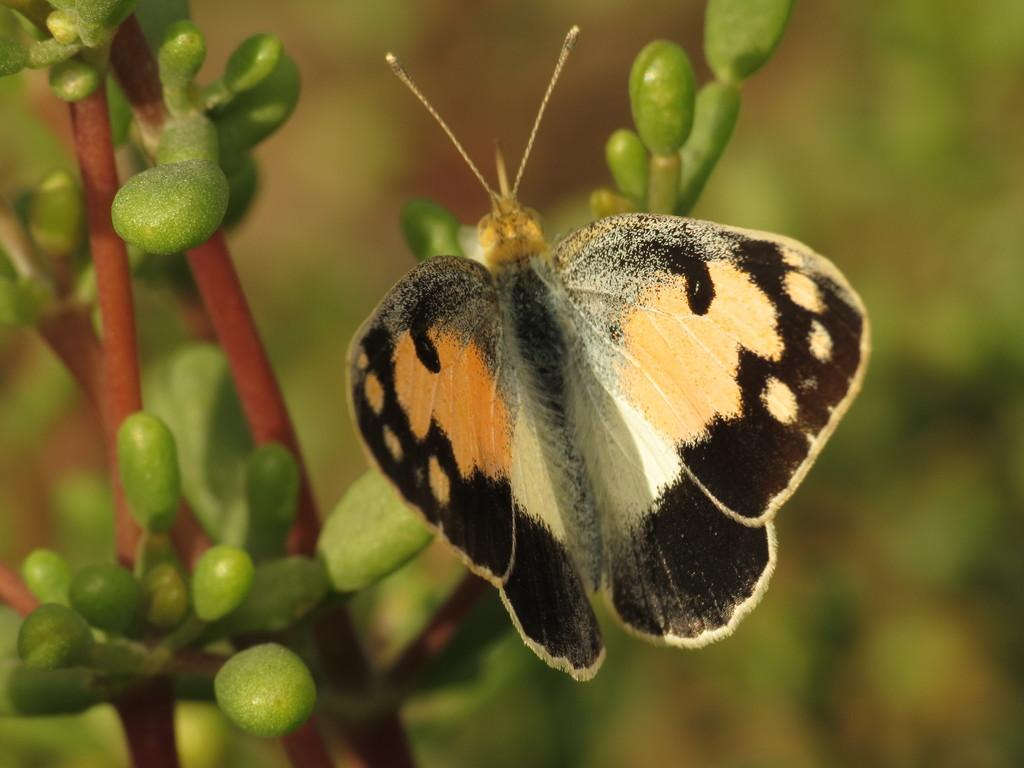What is the main subject of the image? There is a butterfly in the image. Where is the butterfly located? The butterfly is on a pant. What colors can be seen on the butterfly? The butterfly has black, brown, and cream colors. Can you describe the background of the image? The background of the image is blurred. How does the butterfly measure the length of the pant in the image? Butterflies do not have the ability to measure objects, so this question cannot be answered based on the information provided. 